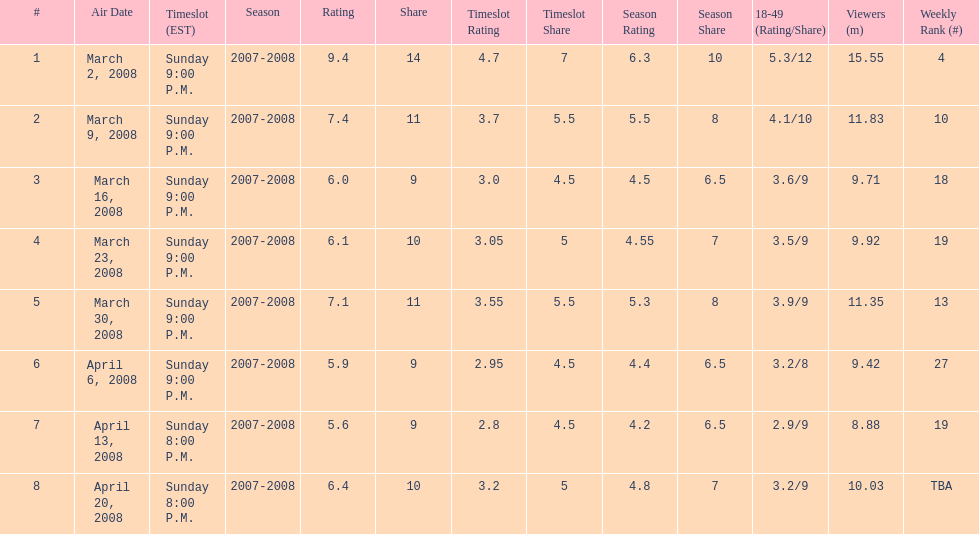How many shows had more than 10 million viewers? 4. 